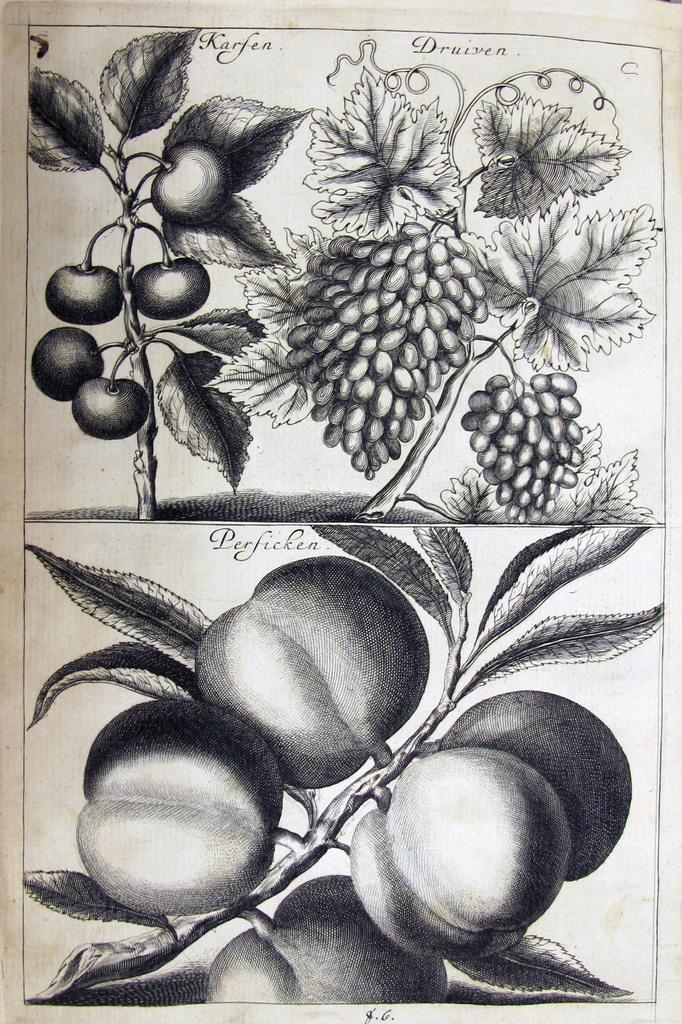Can you describe this image briefly? It is an pencil art on the paper where there are grapes , tomatoes and some fruits or vegetables hanging to the plants. 